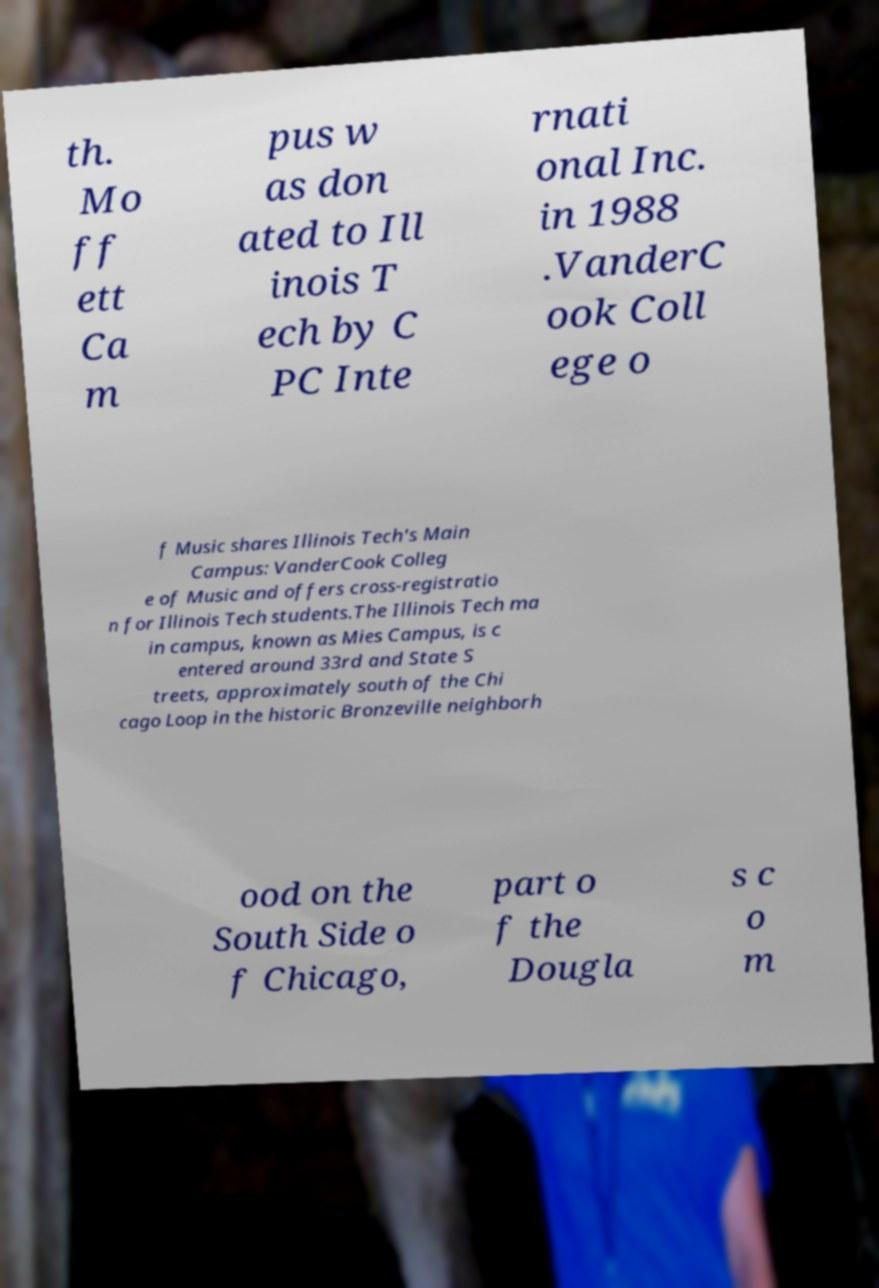For documentation purposes, I need the text within this image transcribed. Could you provide that? th. Mo ff ett Ca m pus w as don ated to Ill inois T ech by C PC Inte rnati onal Inc. in 1988 .VanderC ook Coll ege o f Music shares Illinois Tech's Main Campus: VanderCook Colleg e of Music and offers cross-registratio n for Illinois Tech students.The Illinois Tech ma in campus, known as Mies Campus, is c entered around 33rd and State S treets, approximately south of the Chi cago Loop in the historic Bronzeville neighborh ood on the South Side o f Chicago, part o f the Dougla s c o m 